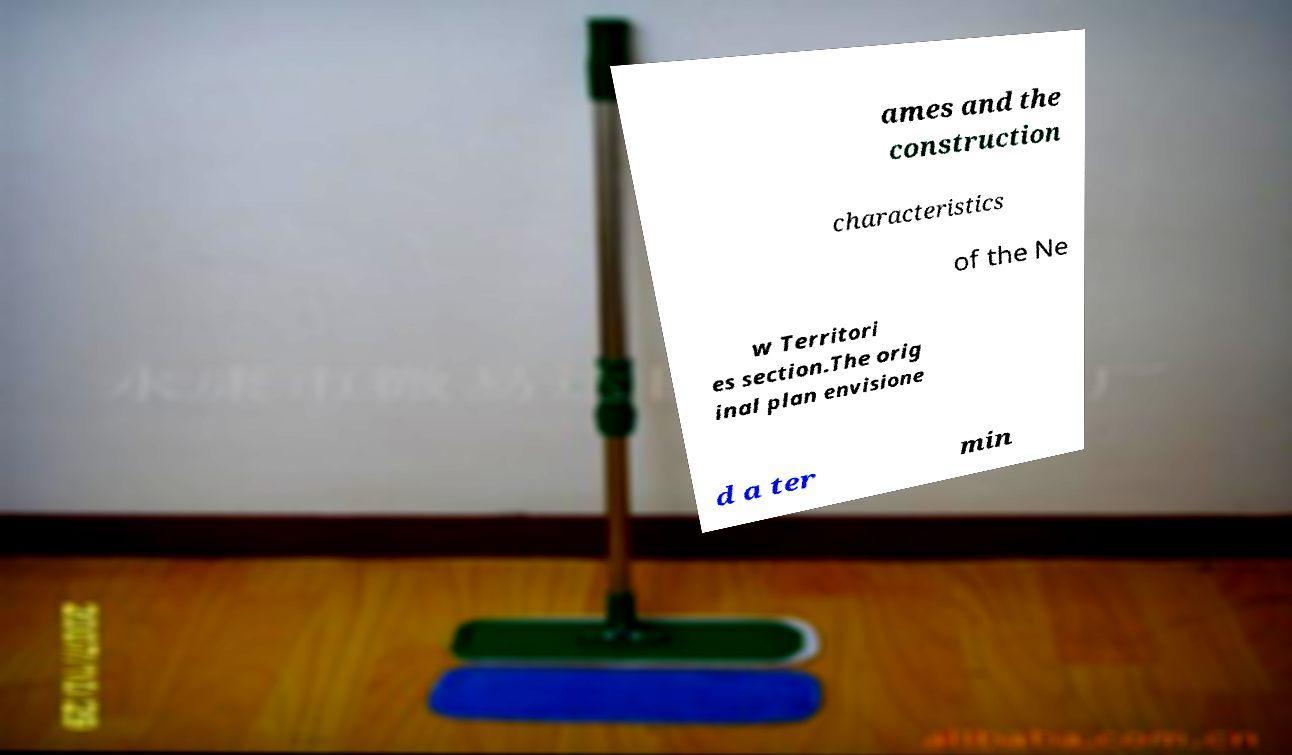Can you read and provide the text displayed in the image?This photo seems to have some interesting text. Can you extract and type it out for me? ames and the construction characteristics of the Ne w Territori es section.The orig inal plan envisione d a ter min 